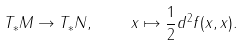<formula> <loc_0><loc_0><loc_500><loc_500>T _ { * } M \to T _ { * } N , \quad x \mapsto \frac { 1 } { 2 } d ^ { 2 } f ( x , x ) .</formula> 